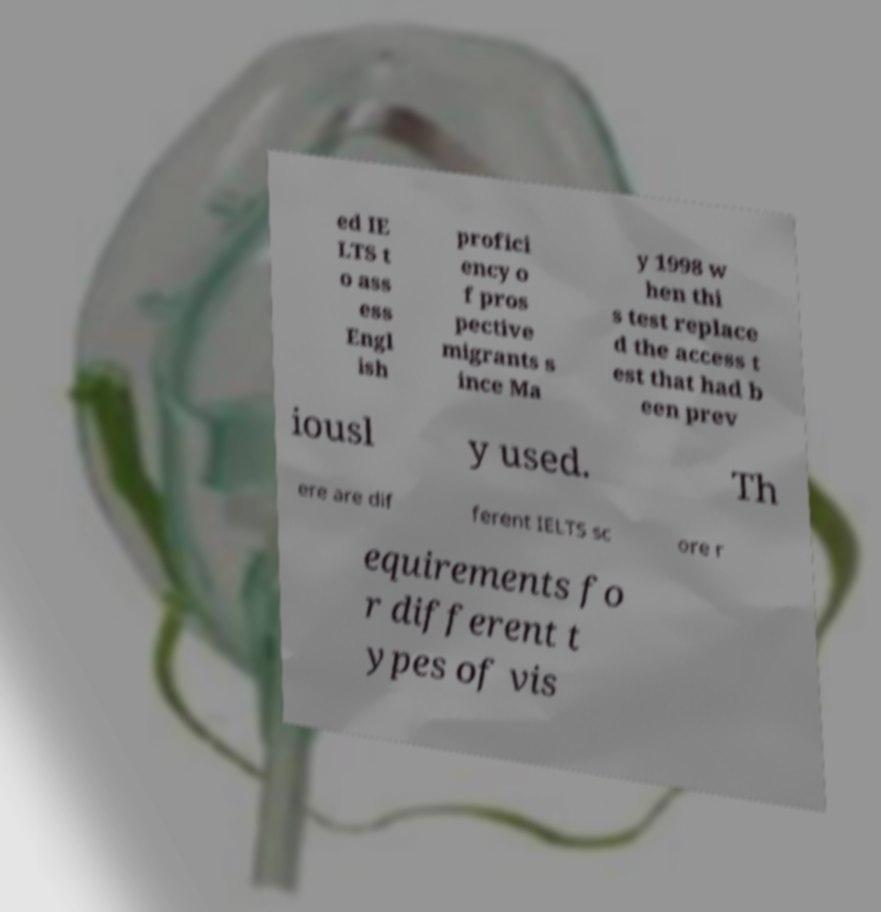I need the written content from this picture converted into text. Can you do that? ed IE LTS t o ass ess Engl ish profici ency o f pros pective migrants s ince Ma y 1998 w hen thi s test replace d the access t est that had b een prev iousl y used. Th ere are dif ferent IELTS sc ore r equirements fo r different t ypes of vis 